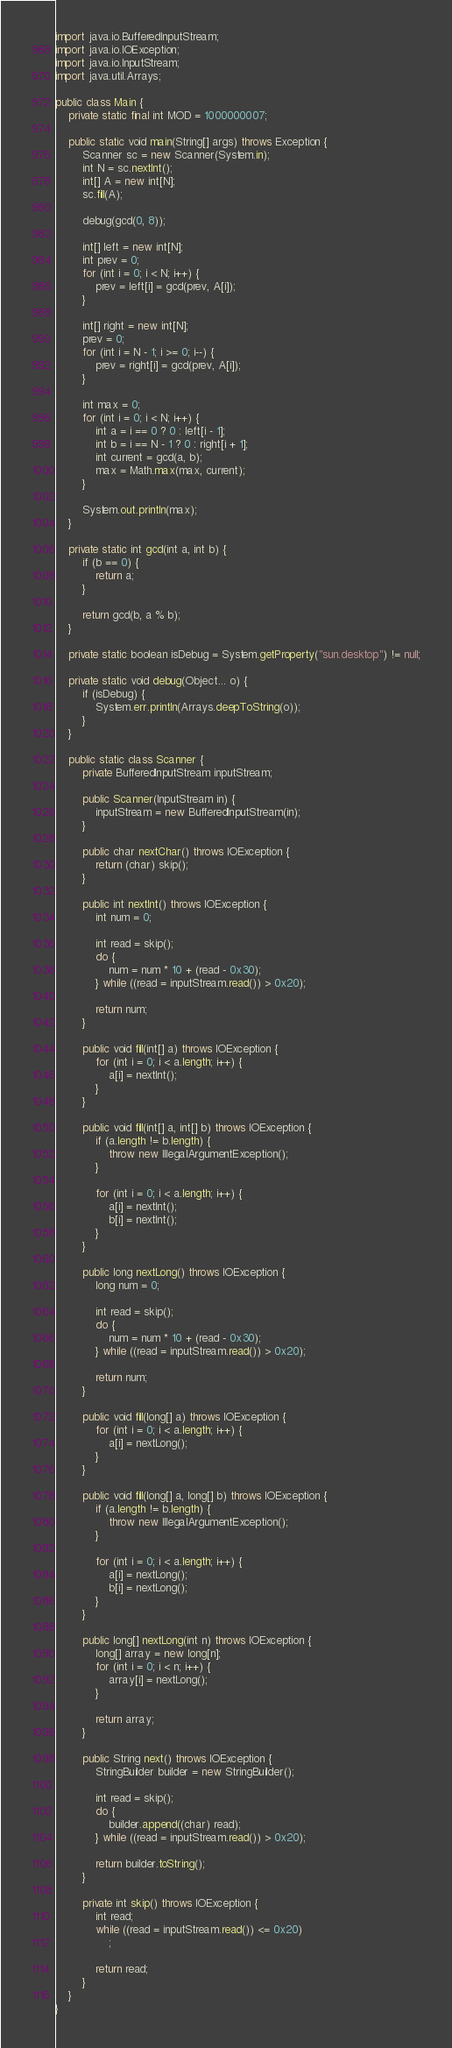Convert code to text. <code><loc_0><loc_0><loc_500><loc_500><_Java_>import java.io.BufferedInputStream;
import java.io.IOException;
import java.io.InputStream;
import java.util.Arrays;

public class Main {
	private static final int MOD = 1000000007;

	public static void main(String[] args) throws Exception {
		Scanner sc = new Scanner(System.in);
		int N = sc.nextInt();
		int[] A = new int[N];
		sc.fill(A);

		debug(gcd(0, 8));

		int[] left = new int[N];
		int prev = 0;
		for (int i = 0; i < N; i++) {
			prev = left[i] = gcd(prev, A[i]);
		}

		int[] right = new int[N];
		prev = 0;
		for (int i = N - 1; i >= 0; i--) {
			prev = right[i] = gcd(prev, A[i]);
		}

		int max = 0;
		for (int i = 0; i < N; i++) {
			int a = i == 0 ? 0 : left[i - 1];
			int b = i == N - 1 ? 0 : right[i + 1];
			int current = gcd(a, b);
			max = Math.max(max, current);
		}

		System.out.println(max);
	}

	private static int gcd(int a, int b) {
		if (b == 0) {
			return a;
		}

		return gcd(b, a % b);
	}

	private static boolean isDebug = System.getProperty("sun.desktop") != null;

	private static void debug(Object... o) {
		if (isDebug) {
			System.err.println(Arrays.deepToString(o));
		}
	}

	public static class Scanner {
		private BufferedInputStream inputStream;

		public Scanner(InputStream in) {
			inputStream = new BufferedInputStream(in);
		}

		public char nextChar() throws IOException {
			return (char) skip();
		}

		public int nextInt() throws IOException {
			int num = 0;

			int read = skip();
			do {
				num = num * 10 + (read - 0x30);
			} while ((read = inputStream.read()) > 0x20);

			return num;
		}

		public void fill(int[] a) throws IOException {
			for (int i = 0; i < a.length; i++) {
				a[i] = nextInt();
			}
		}

		public void fill(int[] a, int[] b) throws IOException {
			if (a.length != b.length) {
				throw new IllegalArgumentException();
			}

			for (int i = 0; i < a.length; i++) {
				a[i] = nextInt();
				b[i] = nextInt();
			}
		}

		public long nextLong() throws IOException {
			long num = 0;

			int read = skip();
			do {
				num = num * 10 + (read - 0x30);
			} while ((read = inputStream.read()) > 0x20);

			return num;
		}

		public void fill(long[] a) throws IOException {
			for (int i = 0; i < a.length; i++) {
				a[i] = nextLong();
			}
		}

		public void fill(long[] a, long[] b) throws IOException {
			if (a.length != b.length) {
				throw new IllegalArgumentException();
			}

			for (int i = 0; i < a.length; i++) {
				a[i] = nextLong();
				b[i] = nextLong();
			}
		}

		public long[] nextLong(int n) throws IOException {
			long[] array = new long[n];
			for (int i = 0; i < n; i++) {
				array[i] = nextLong();
			}

			return array;
		}

		public String next() throws IOException {
			StringBuilder builder = new StringBuilder();

			int read = skip();
			do {
				builder.append((char) read);
			} while ((read = inputStream.read()) > 0x20);

			return builder.toString();
		}

		private int skip() throws IOException {
			int read;
			while ((read = inputStream.read()) <= 0x20)
				;

			return read;
		}
	}
}</code> 